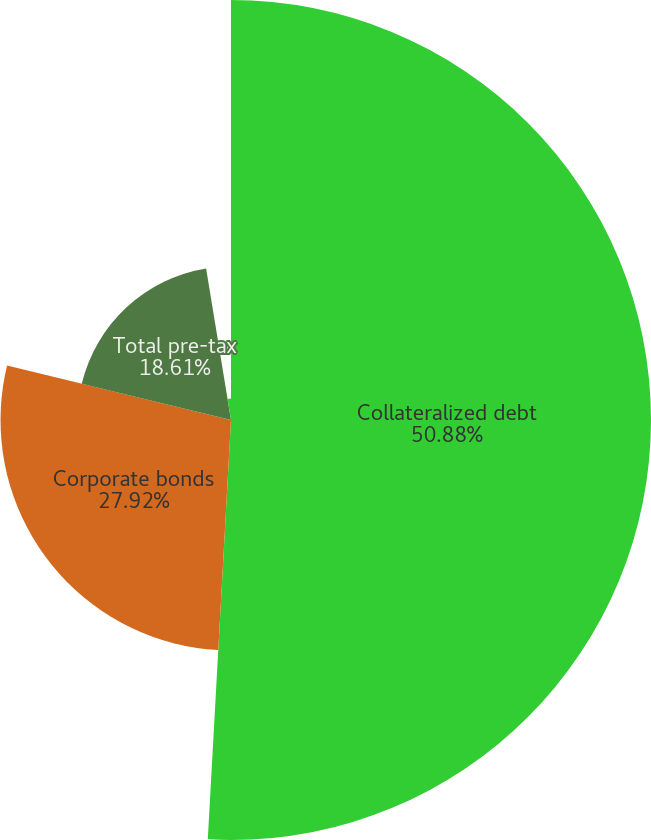Convert chart to OTSL. <chart><loc_0><loc_0><loc_500><loc_500><pie_chart><fcel>Collateralized debt<fcel>Corporate bonds<fcel>Total pre-tax<fcel>After tax<nl><fcel>50.88%<fcel>27.92%<fcel>18.61%<fcel>2.59%<nl></chart> 